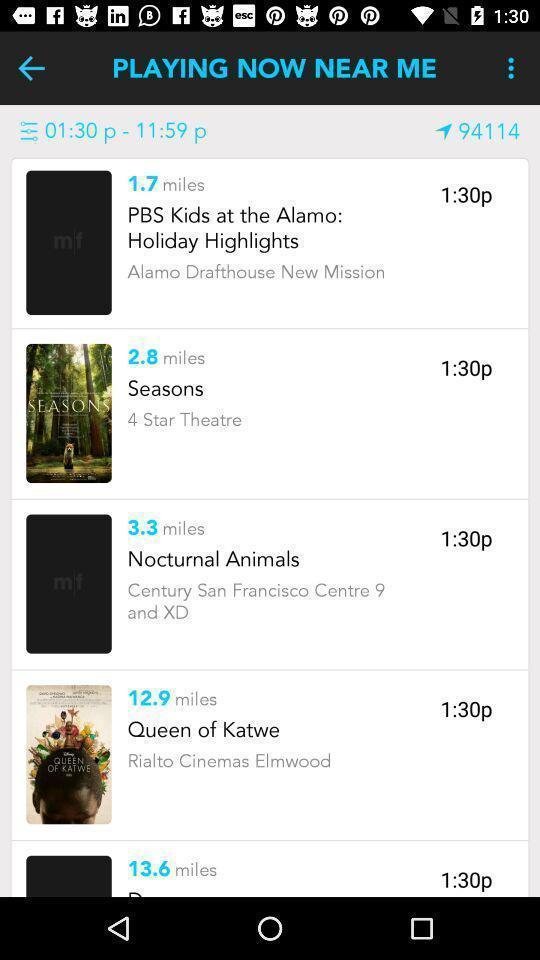Describe this image in words. Page displaying with list of shows playing in application. 